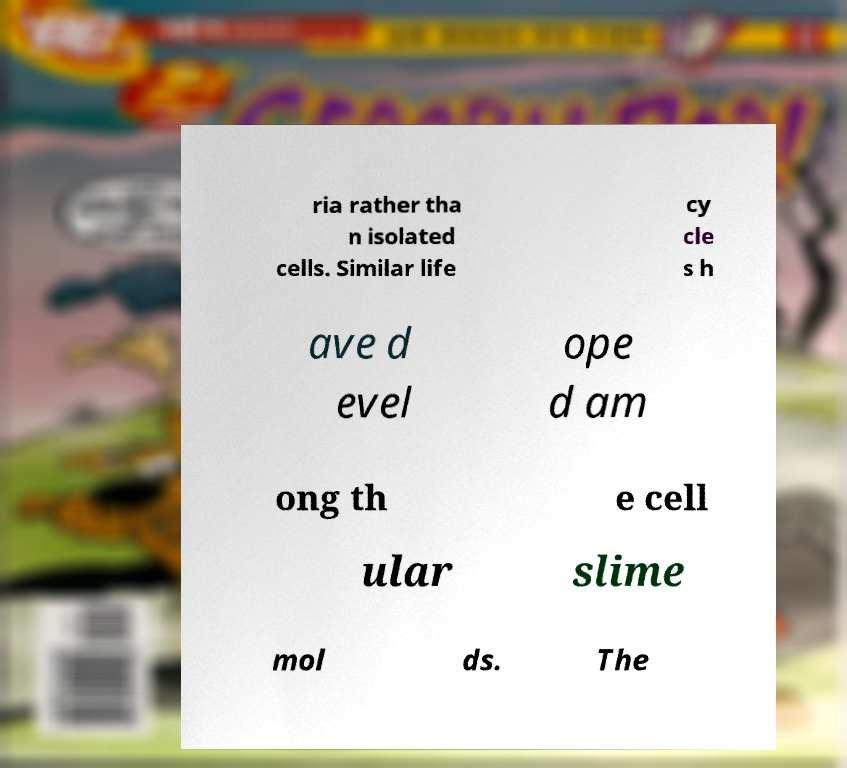Could you extract and type out the text from this image? ria rather tha n isolated cells. Similar life cy cle s h ave d evel ope d am ong th e cell ular slime mol ds. The 